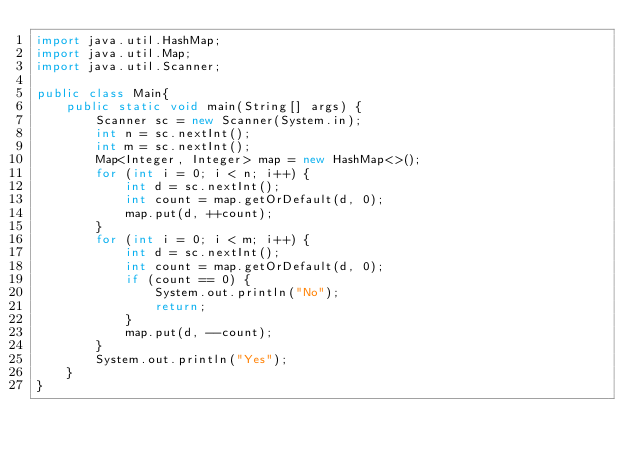<code> <loc_0><loc_0><loc_500><loc_500><_Java_>import java.util.HashMap;
import java.util.Map;
import java.util.Scanner;

public class Main{
    public static void main(String[] args) {
        Scanner sc = new Scanner(System.in);
        int n = sc.nextInt();
        int m = sc.nextInt();
        Map<Integer, Integer> map = new HashMap<>();
        for (int i = 0; i < n; i++) {
            int d = sc.nextInt();
            int count = map.getOrDefault(d, 0);
            map.put(d, ++count);
        }
        for (int i = 0; i < m; i++) {
            int d = sc.nextInt();
            int count = map.getOrDefault(d, 0);
            if (count == 0) {
                System.out.println("No");
                return;
            }
            map.put(d, --count);
        }
        System.out.println("Yes");
    }
}
</code> 